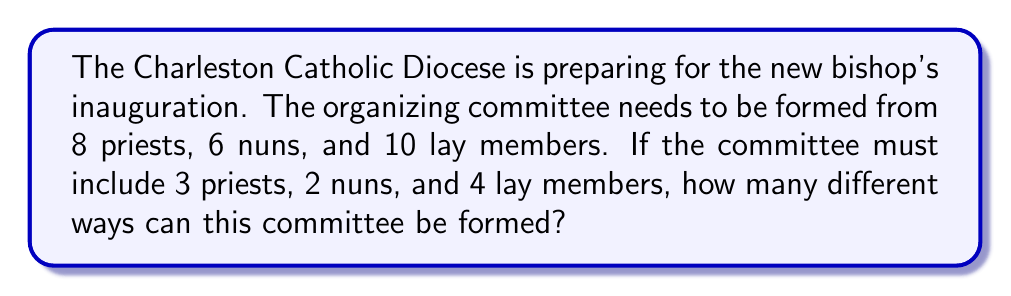Provide a solution to this math problem. Let's break this down step-by-step:

1) We need to choose:
   - 3 priests out of 8
   - 2 nuns out of 6
   - 4 lay members out of 10

2) For each of these selections, we can use the combination formula:
   $${n \choose k} = \frac{n!}{k!(n-k)!}$$

3) For the priests: 
   $${8 \choose 3} = \frac{8!}{3!(8-3)!} = \frac{8!}{3!5!} = 56$$

4) For the nuns:
   $${6 \choose 2} = \frac{6!}{2!(6-2)!} = \frac{6!}{2!4!} = 15$$

5) For the lay members:
   $${10 \choose 4} = \frac{10!}{4!(10-4)!} = \frac{10!}{4!6!} = 210$$

6) By the multiplication principle, the total number of ways to form the committee is the product of these three numbers:

   $$56 \times 15 \times 210 = 176,400$$

Therefore, there are 176,400 different ways to form the committee.
Answer: 176,400 